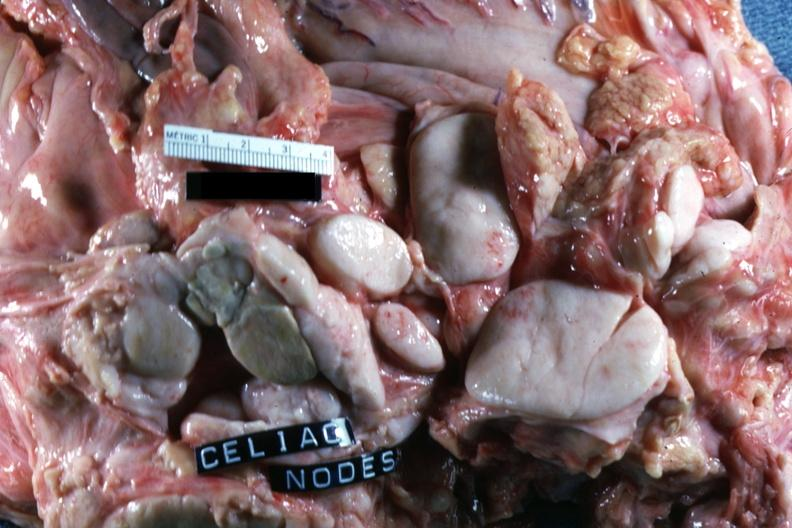s surface present?
Answer the question using a single word or phrase. No 